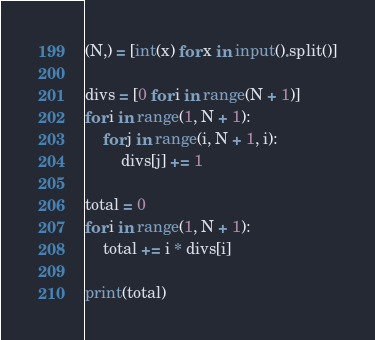<code> <loc_0><loc_0><loc_500><loc_500><_Python_>(N,) = [int(x) for x in input().split()]

divs = [0 for i in range(N + 1)]
for i in range(1, N + 1):
    for j in range(i, N + 1, i):
        divs[j] += 1

total = 0
for i in range(1, N + 1):
    total += i * divs[i]

print(total)
</code> 